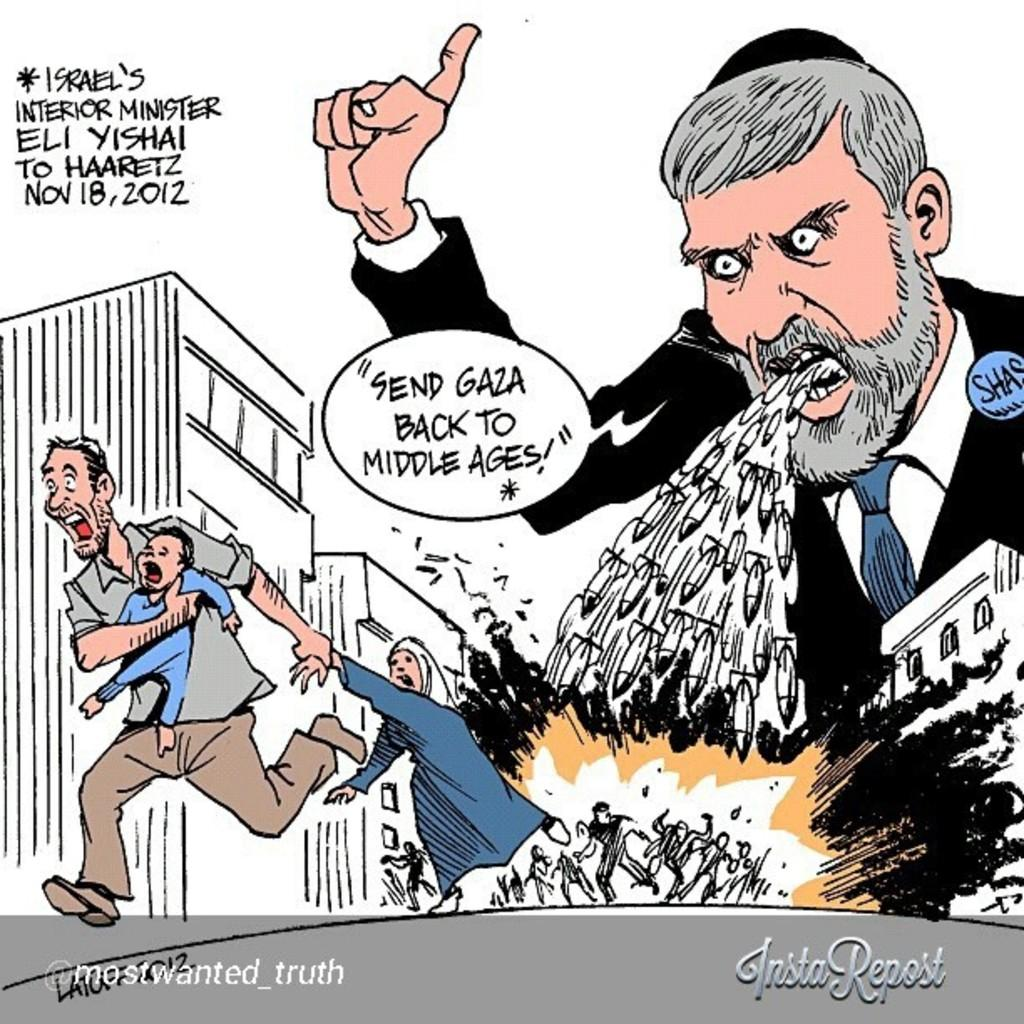What is the main subject of the image? The main subject of the image is a poster. What can be seen on the poster? There are persons, text, and buildings depicted on the poster. Where is the text located on the poster? The text is located both at the top and bottom of the poster. What is present at the bottom of the image? There is text at the bottom of the image. What type of weather is depicted in the image? There is no weather depicted in the image, as it features a poster with various elements but no indication of weather conditions. 